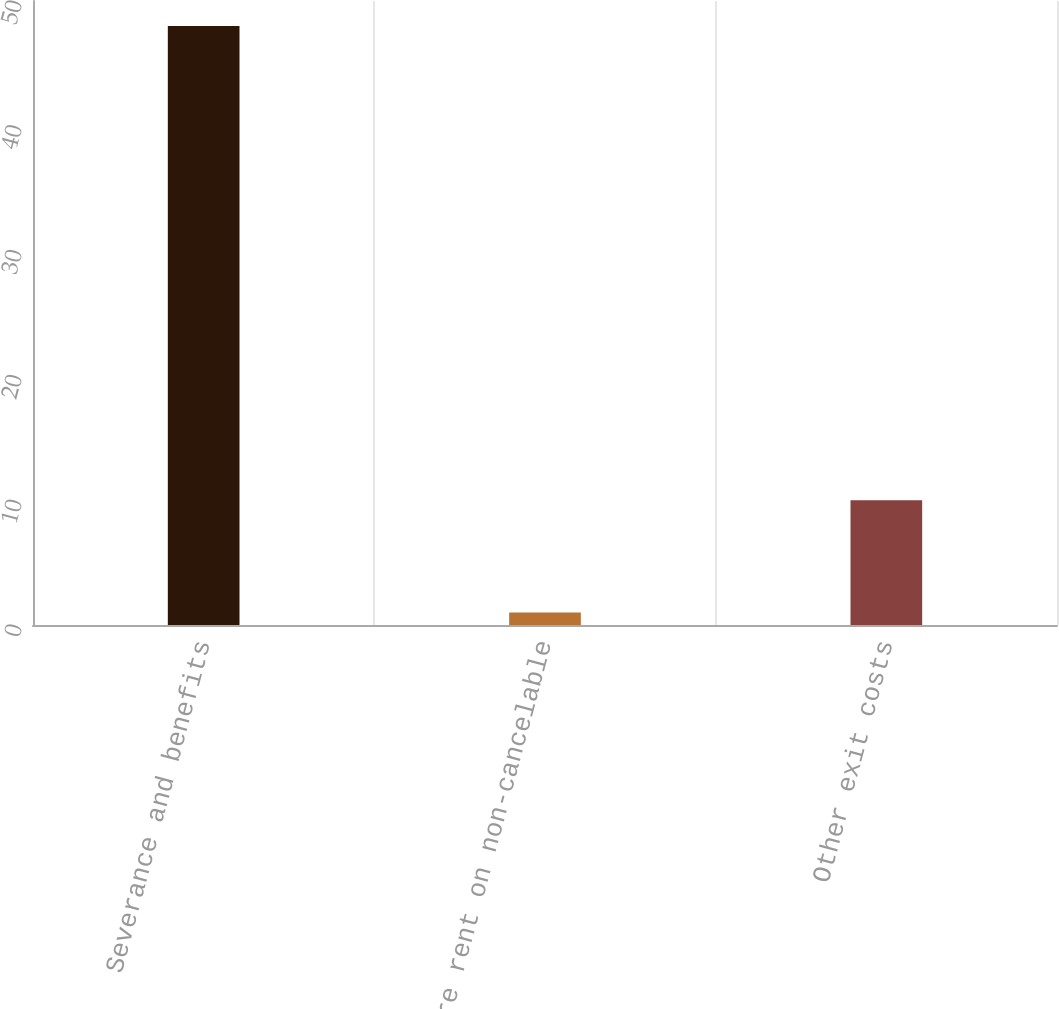Convert chart. <chart><loc_0><loc_0><loc_500><loc_500><bar_chart><fcel>Severance and benefits<fcel>Future rent on non-cancelable<fcel>Other exit costs<nl><fcel>48<fcel>1<fcel>10<nl></chart> 